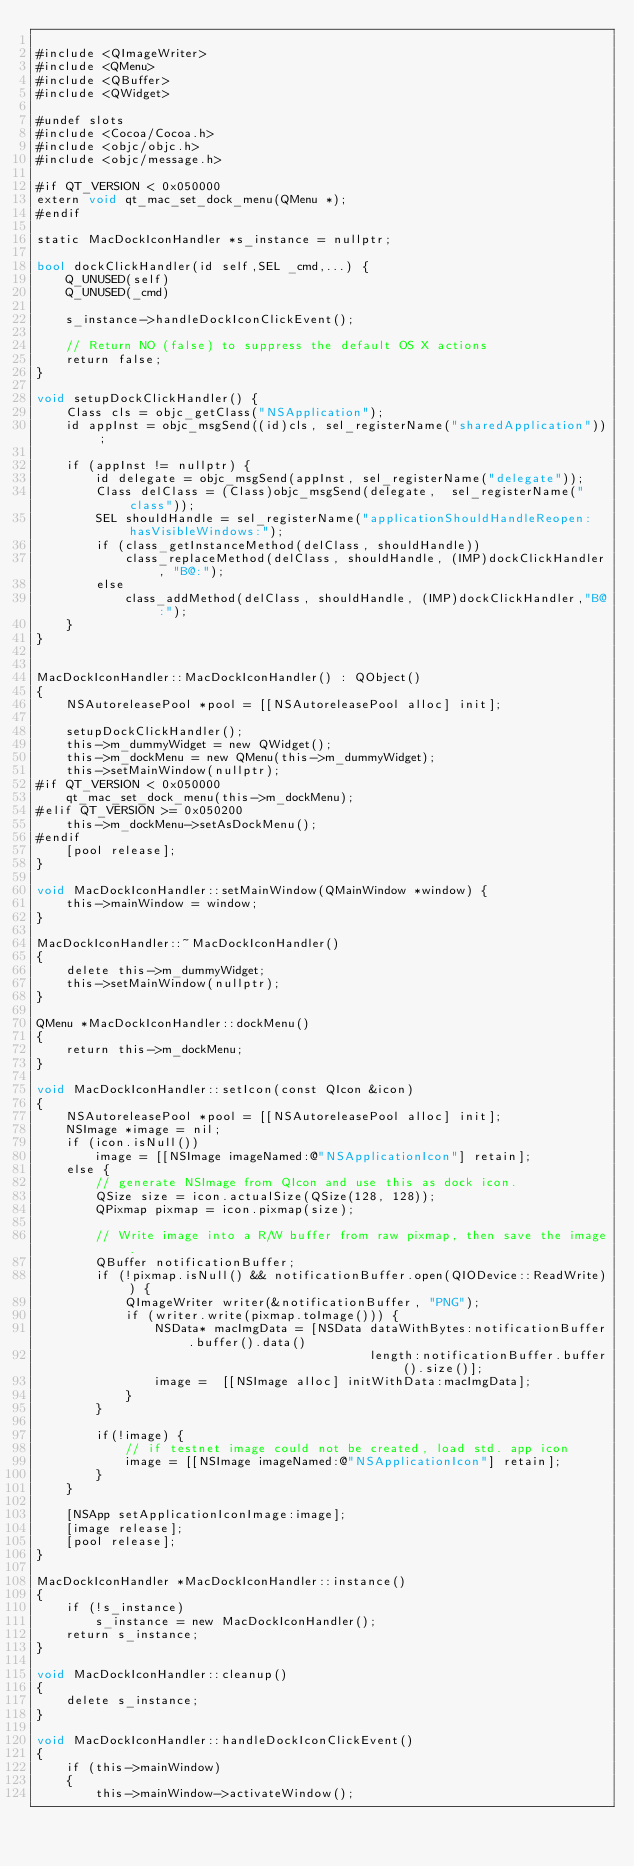Convert code to text. <code><loc_0><loc_0><loc_500><loc_500><_ObjectiveC_>
#include <QImageWriter>
#include <QMenu>
#include <QBuffer>
#include <QWidget>

#undef slots
#include <Cocoa/Cocoa.h>
#include <objc/objc.h>
#include <objc/message.h>

#if QT_VERSION < 0x050000
extern void qt_mac_set_dock_menu(QMenu *);
#endif

static MacDockIconHandler *s_instance = nullptr;

bool dockClickHandler(id self,SEL _cmd,...) {
    Q_UNUSED(self)
    Q_UNUSED(_cmd)
    
    s_instance->handleDockIconClickEvent();
    
    // Return NO (false) to suppress the default OS X actions
    return false;
}

void setupDockClickHandler() {
    Class cls = objc_getClass("NSApplication");
    id appInst = objc_msgSend((id)cls, sel_registerName("sharedApplication"));
    
    if (appInst != nullptr) {
        id delegate = objc_msgSend(appInst, sel_registerName("delegate"));
        Class delClass = (Class)objc_msgSend(delegate,  sel_registerName("class"));
        SEL shouldHandle = sel_registerName("applicationShouldHandleReopen:hasVisibleWindows:");
        if (class_getInstanceMethod(delClass, shouldHandle))
            class_replaceMethod(delClass, shouldHandle, (IMP)dockClickHandler, "B@:");
        else
            class_addMethod(delClass, shouldHandle, (IMP)dockClickHandler,"B@:");
    }
}


MacDockIconHandler::MacDockIconHandler() : QObject()
{
    NSAutoreleasePool *pool = [[NSAutoreleasePool alloc] init];

    setupDockClickHandler();
    this->m_dummyWidget = new QWidget();
    this->m_dockMenu = new QMenu(this->m_dummyWidget);
    this->setMainWindow(nullptr);
#if QT_VERSION < 0x050000
    qt_mac_set_dock_menu(this->m_dockMenu);
#elif QT_VERSION >= 0x050200
    this->m_dockMenu->setAsDockMenu();
#endif
    [pool release];
}

void MacDockIconHandler::setMainWindow(QMainWindow *window) {
    this->mainWindow = window;
}

MacDockIconHandler::~MacDockIconHandler()
{
    delete this->m_dummyWidget;
    this->setMainWindow(nullptr);
}

QMenu *MacDockIconHandler::dockMenu()
{
    return this->m_dockMenu;
}

void MacDockIconHandler::setIcon(const QIcon &icon)
{
    NSAutoreleasePool *pool = [[NSAutoreleasePool alloc] init];
    NSImage *image = nil;
    if (icon.isNull())
        image = [[NSImage imageNamed:@"NSApplicationIcon"] retain];
    else {
        // generate NSImage from QIcon and use this as dock icon.
        QSize size = icon.actualSize(QSize(128, 128));
        QPixmap pixmap = icon.pixmap(size);

        // Write image into a R/W buffer from raw pixmap, then save the image.
        QBuffer notificationBuffer;
        if (!pixmap.isNull() && notificationBuffer.open(QIODevice::ReadWrite)) {
            QImageWriter writer(&notificationBuffer, "PNG");
            if (writer.write(pixmap.toImage())) {
                NSData* macImgData = [NSData dataWithBytes:notificationBuffer.buffer().data()
                                             length:notificationBuffer.buffer().size()];
                image =  [[NSImage alloc] initWithData:macImgData];
            }
        }

        if(!image) {
            // if testnet image could not be created, load std. app icon
            image = [[NSImage imageNamed:@"NSApplicationIcon"] retain];
        }
    }

    [NSApp setApplicationIconImage:image];
    [image release];
    [pool release];
}

MacDockIconHandler *MacDockIconHandler::instance()
{
    if (!s_instance)
        s_instance = new MacDockIconHandler();
    return s_instance;
}

void MacDockIconHandler::cleanup()
{
    delete s_instance;
}

void MacDockIconHandler::handleDockIconClickEvent()
{
    if (this->mainWindow)
    {
        this->mainWindow->activateWindow();</code> 